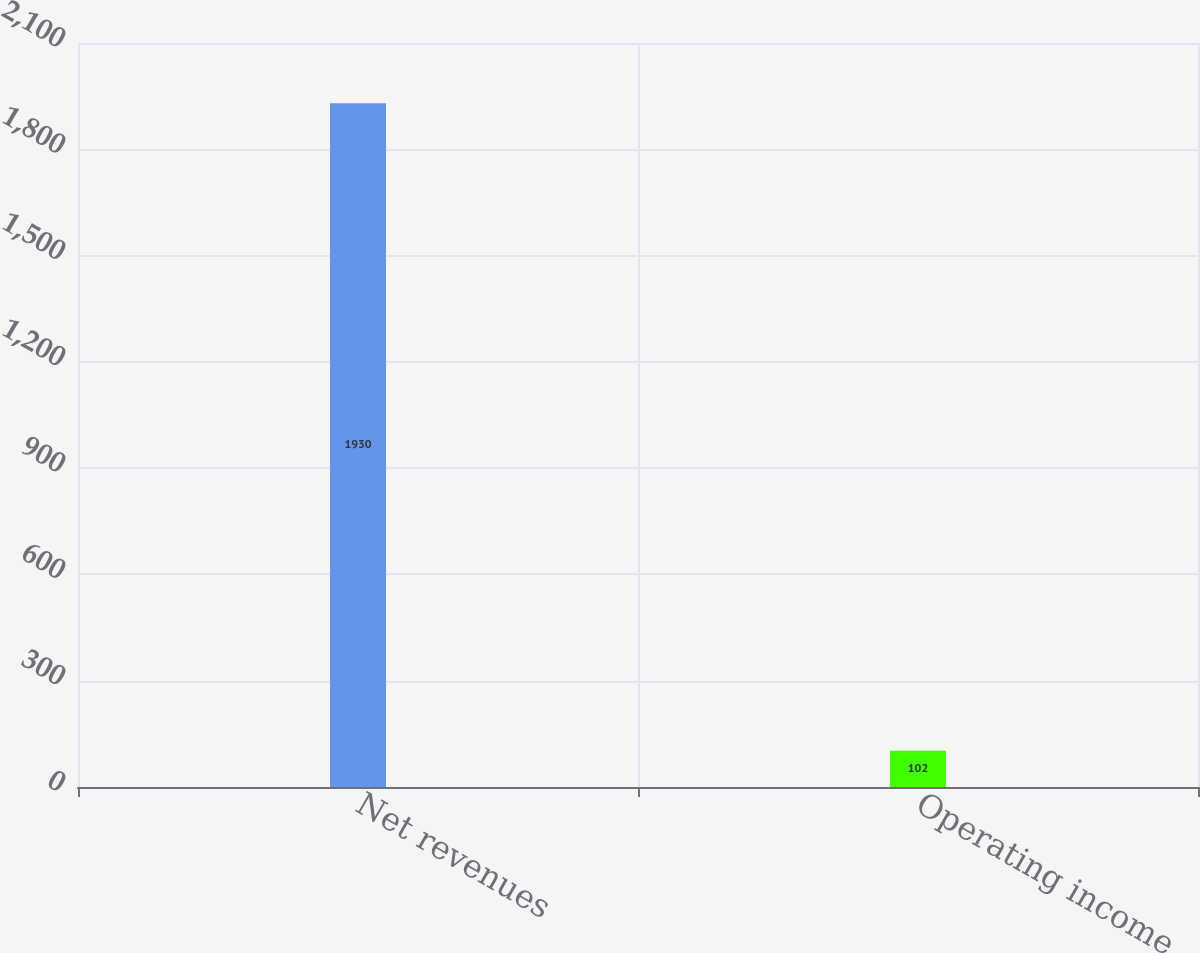<chart> <loc_0><loc_0><loc_500><loc_500><bar_chart><fcel>Net revenues<fcel>Operating income<nl><fcel>1930<fcel>102<nl></chart> 